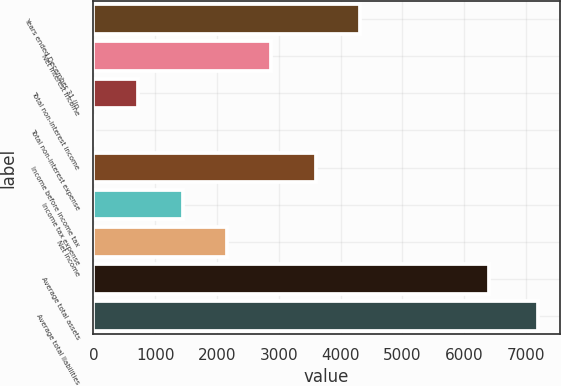Convert chart. <chart><loc_0><loc_0><loc_500><loc_500><bar_chart><fcel>Years ended December 31 (in<fcel>Net interest income<fcel>Total non-interest income<fcel>Total non-interest expense<fcel>Income before income tax<fcel>Income tax expense<fcel>Net income<fcel>Average total assets<fcel>Average total liabilities<nl><fcel>4315.8<fcel>2879.5<fcel>725.05<fcel>6.9<fcel>3597.65<fcel>1443.2<fcel>2161.35<fcel>6399.3<fcel>7188.4<nl></chart> 